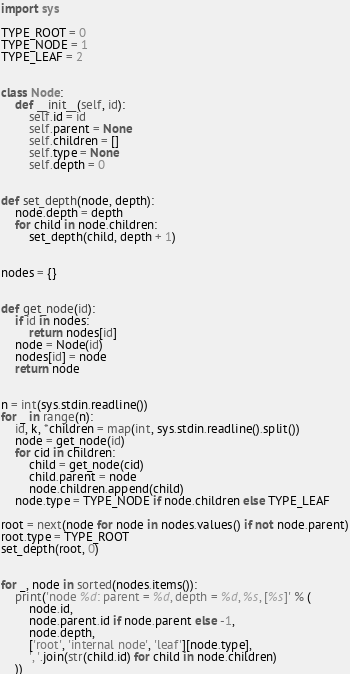<code> <loc_0><loc_0><loc_500><loc_500><_Python_>import sys

TYPE_ROOT = 0
TYPE_NODE = 1
TYPE_LEAF = 2


class Node:
    def __init__(self, id):
        self.id = id
        self.parent = None
        self.children = []
        self.type = None
        self.depth = 0


def set_depth(node, depth):
    node.depth = depth
    for child in node.children:
        set_depth(child, depth + 1)


nodes = {}


def get_node(id):
    if id in nodes:
        return nodes[id]
    node = Node(id)
    nodes[id] = node
    return node


n = int(sys.stdin.readline())
for _ in range(n):
    id, k, *children = map(int, sys.stdin.readline().split())
    node = get_node(id)
    for cid in children:
        child = get_node(cid)
        child.parent = node
        node.children.append(child)
    node.type = TYPE_NODE if node.children else TYPE_LEAF

root = next(node for node in nodes.values() if not node.parent)
root.type = TYPE_ROOT
set_depth(root, 0)


for _, node in sorted(nodes.items()):
    print('node %d: parent = %d, depth = %d, %s, [%s]' % (
        node.id,
        node.parent.id if node.parent else -1,
        node.depth,
        ['root', 'internal node', 'leaf'][node.type],
        ', '.join(str(child.id) for child in node.children)
    ))

</code> 